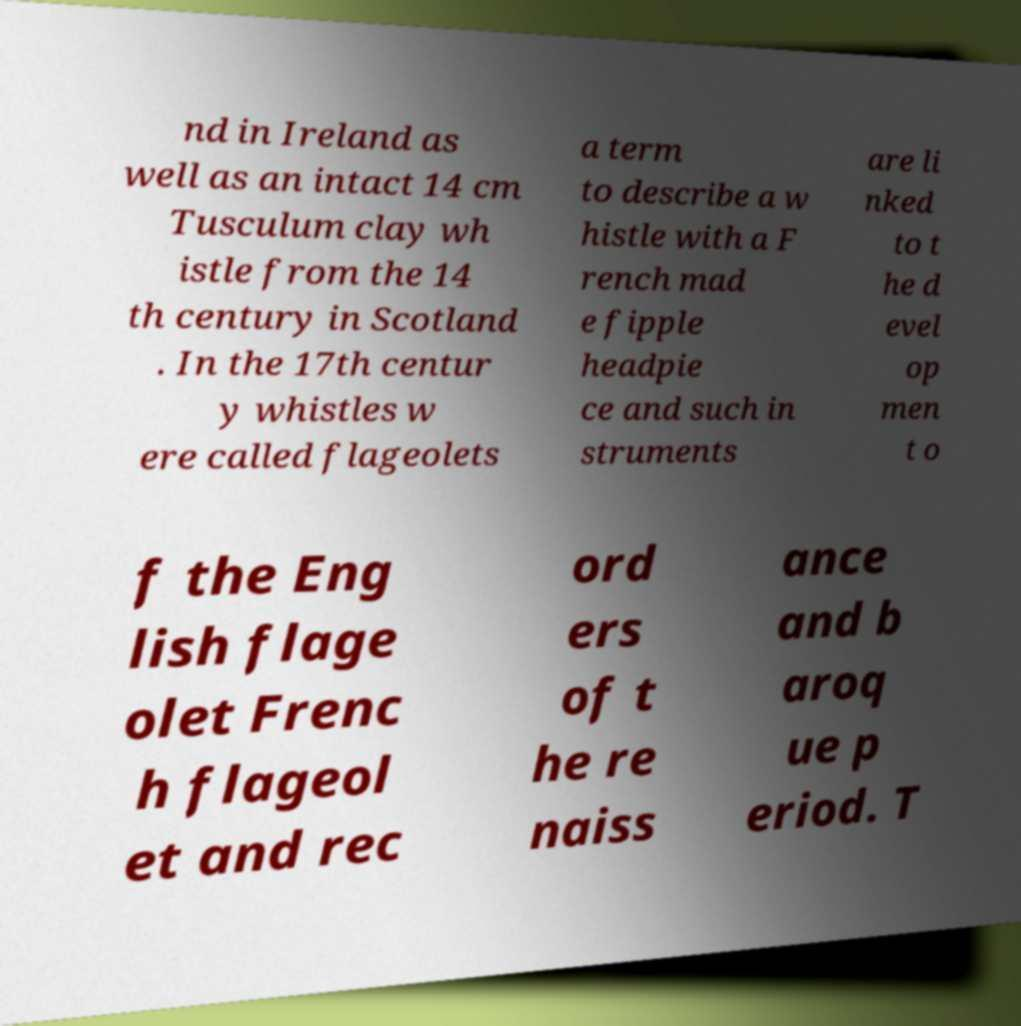Can you read and provide the text displayed in the image?This photo seems to have some interesting text. Can you extract and type it out for me? nd in Ireland as well as an intact 14 cm Tusculum clay wh istle from the 14 th century in Scotland . In the 17th centur y whistles w ere called flageolets a term to describe a w histle with a F rench mad e fipple headpie ce and such in struments are li nked to t he d evel op men t o f the Eng lish flage olet Frenc h flageol et and rec ord ers of t he re naiss ance and b aroq ue p eriod. T 